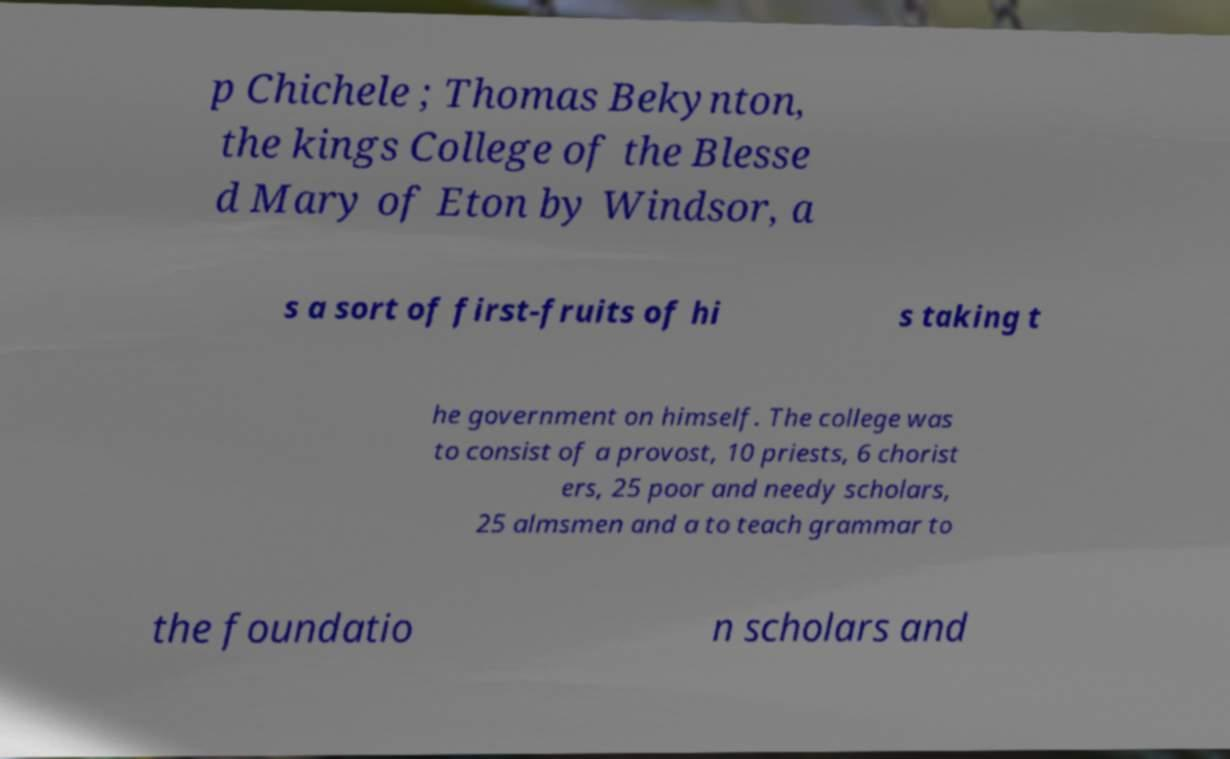Can you accurately transcribe the text from the provided image for me? p Chichele ; Thomas Bekynton, the kings College of the Blesse d Mary of Eton by Windsor, a s a sort of first-fruits of hi s taking t he government on himself. The college was to consist of a provost, 10 priests, 6 chorist ers, 25 poor and needy scholars, 25 almsmen and a to teach grammar to the foundatio n scholars and 